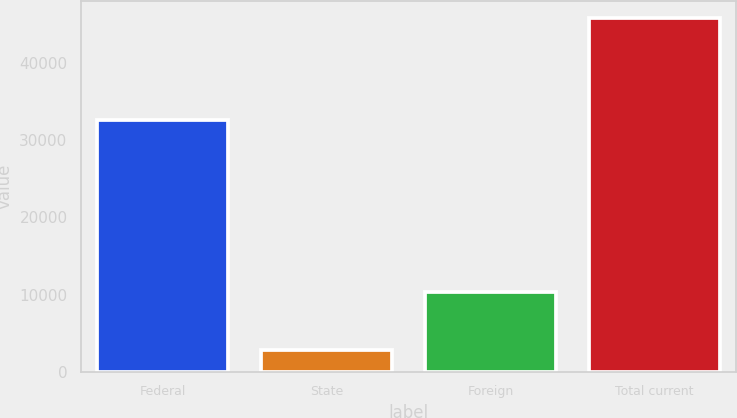Convert chart. <chart><loc_0><loc_0><loc_500><loc_500><bar_chart><fcel>Federal<fcel>State<fcel>Foreign<fcel>Total current<nl><fcel>32602<fcel>2835<fcel>10321<fcel>45758<nl></chart> 